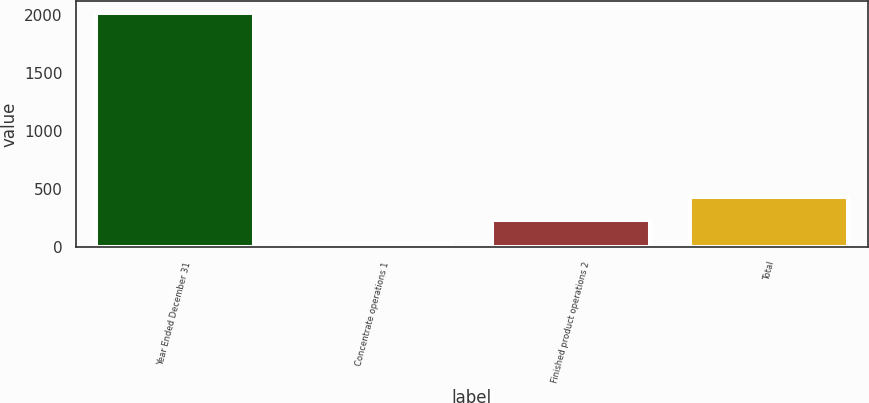<chart> <loc_0><loc_0><loc_500><loc_500><bar_chart><fcel>Year Ended December 31<fcel>Concentrate operations 1<fcel>Finished product operations 2<fcel>Total<nl><fcel>2015<fcel>37<fcel>234.8<fcel>432.6<nl></chart> 